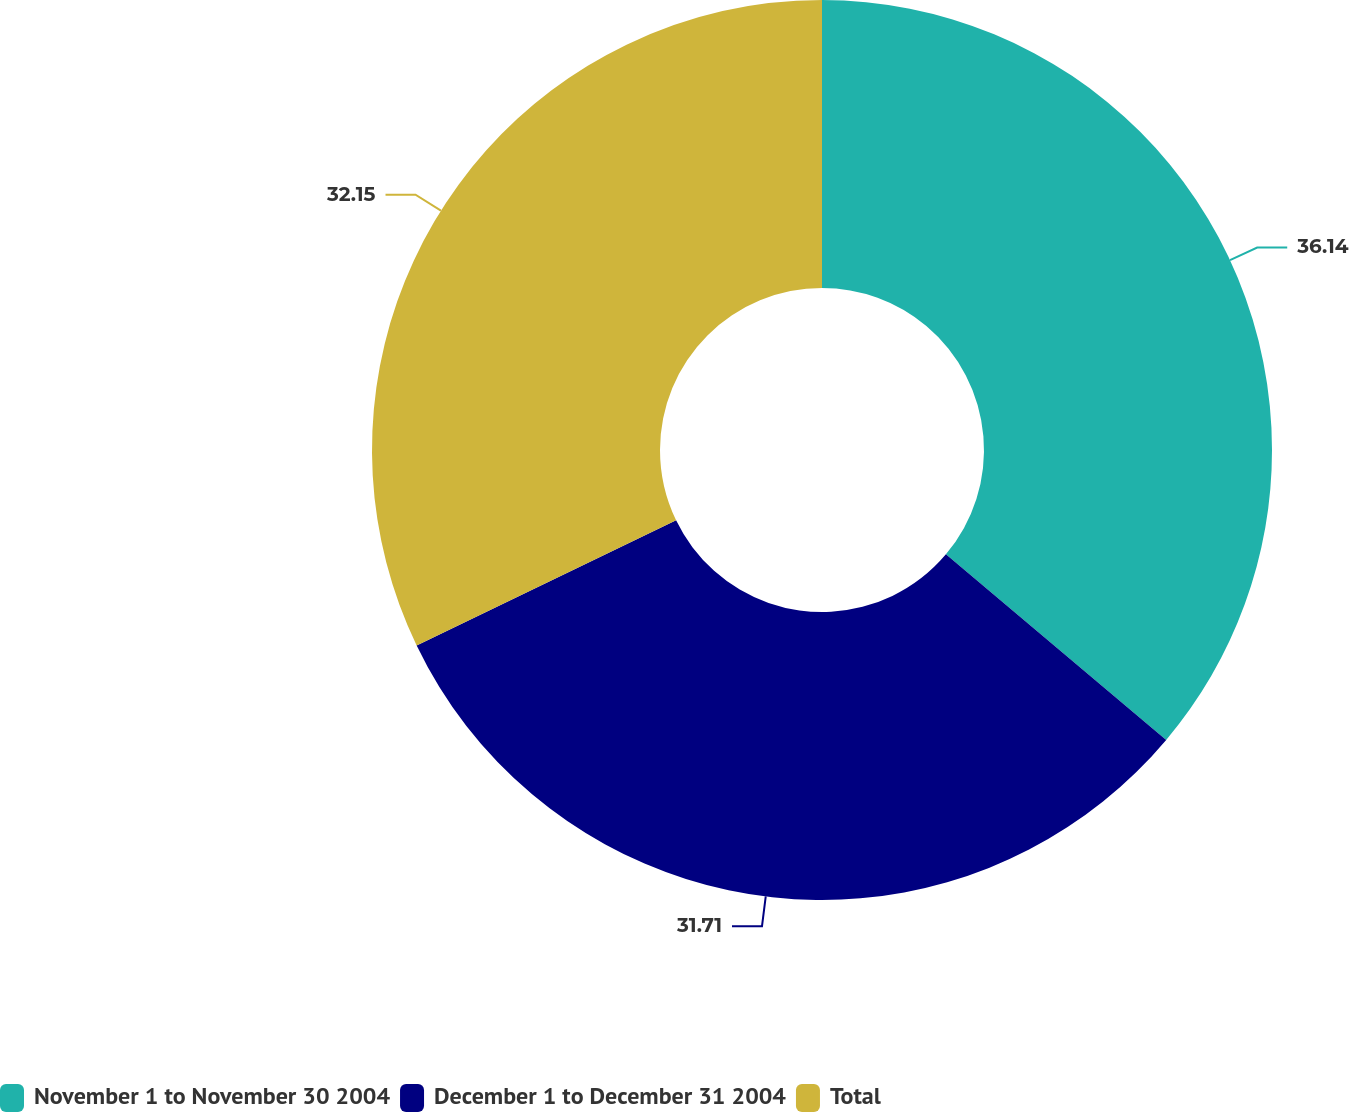<chart> <loc_0><loc_0><loc_500><loc_500><pie_chart><fcel>November 1 to November 30 2004<fcel>December 1 to December 31 2004<fcel>Total<nl><fcel>36.14%<fcel>31.71%<fcel>32.15%<nl></chart> 